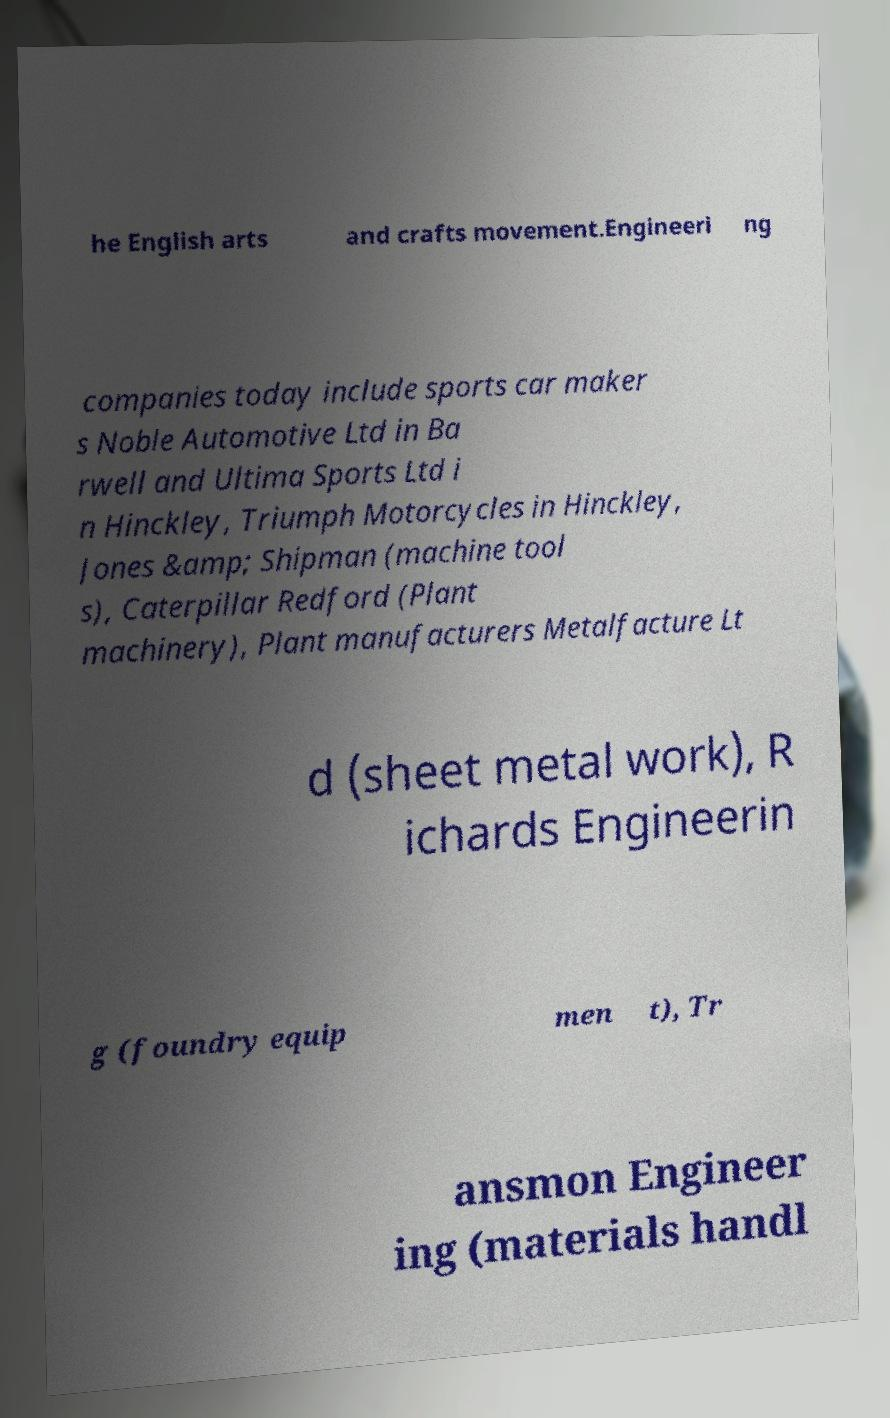Can you read and provide the text displayed in the image?This photo seems to have some interesting text. Can you extract and type it out for me? he English arts and crafts movement.Engineeri ng companies today include sports car maker s Noble Automotive Ltd in Ba rwell and Ultima Sports Ltd i n Hinckley, Triumph Motorcycles in Hinckley, Jones &amp; Shipman (machine tool s), Caterpillar Redford (Plant machinery), Plant manufacturers Metalfacture Lt d (sheet metal work), R ichards Engineerin g (foundry equip men t), Tr ansmon Engineer ing (materials handl 